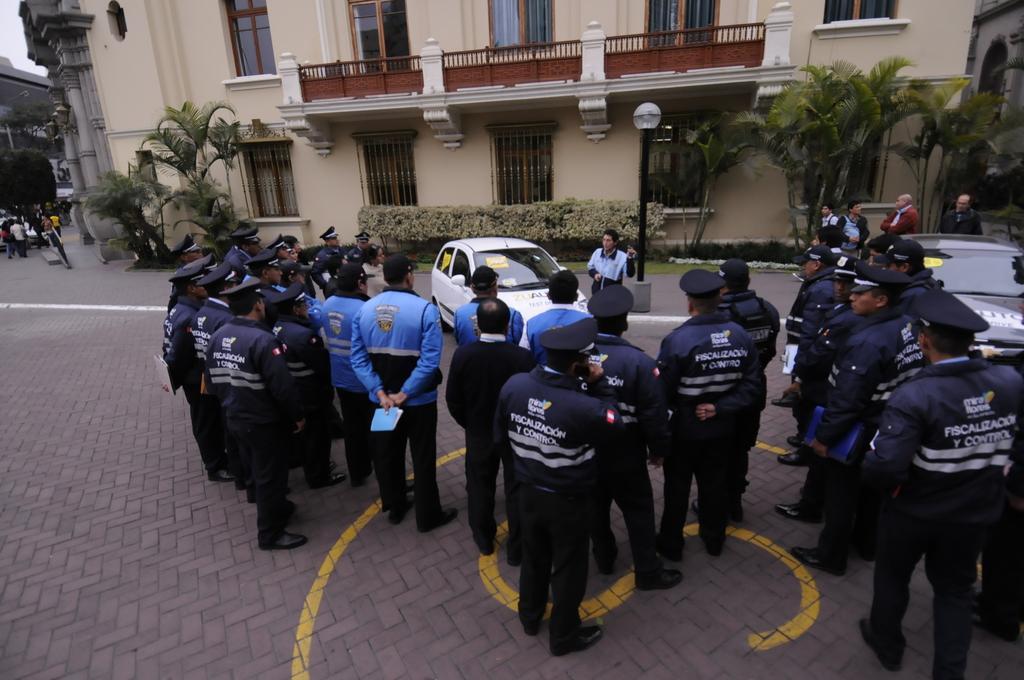Describe this image in one or two sentences. In the foreground I can see a crowd is standing on the road and vehicles. In the background I can see buildings, trees, fence, windows, plants and the sky. This image is taken during a day on the road. 